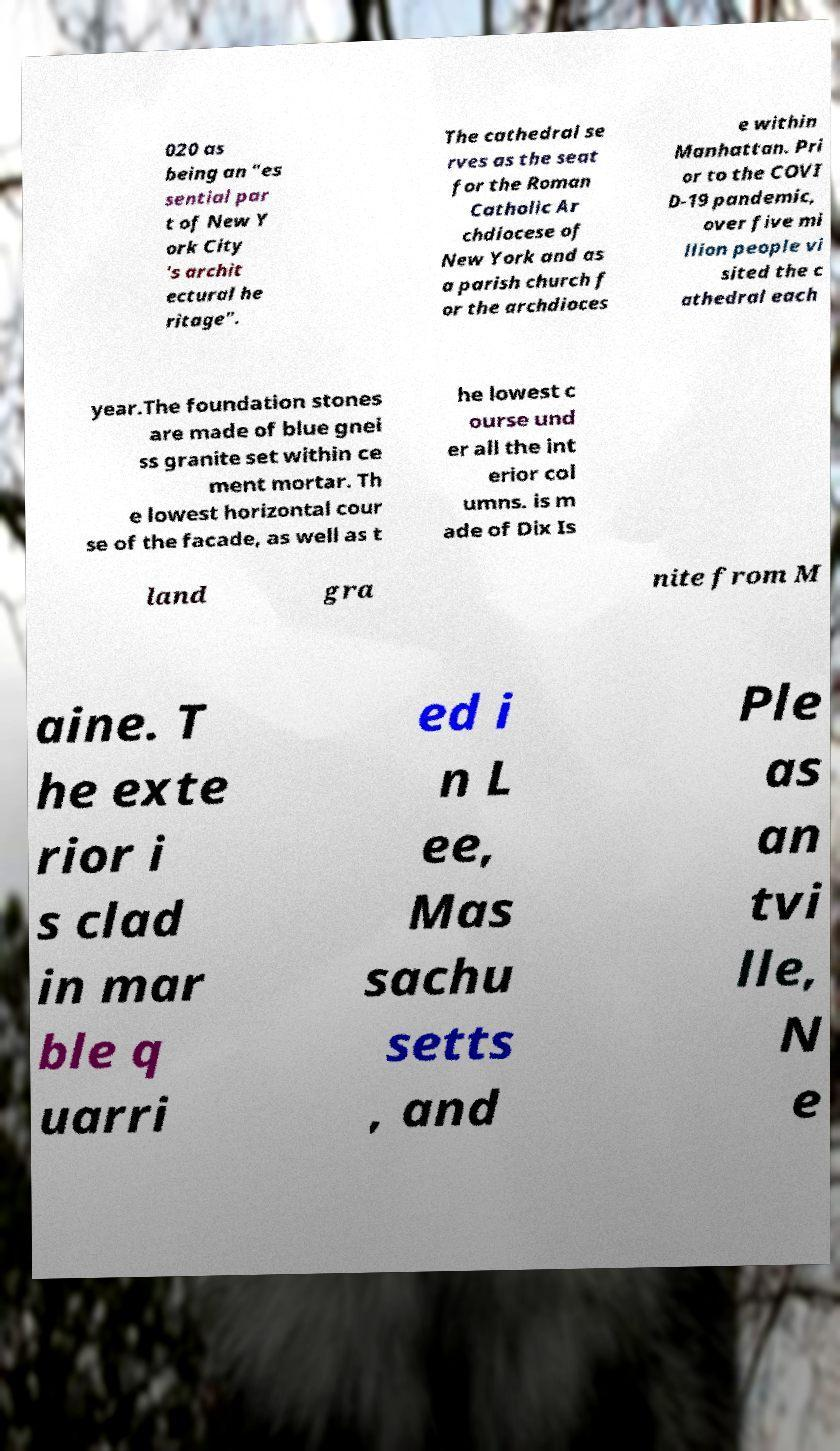Could you extract and type out the text from this image? 020 as being an "es sential par t of New Y ork City 's archit ectural he ritage". The cathedral se rves as the seat for the Roman Catholic Ar chdiocese of New York and as a parish church f or the archdioces e within Manhattan. Pri or to the COVI D-19 pandemic, over five mi llion people vi sited the c athedral each year.The foundation stones are made of blue gnei ss granite set within ce ment mortar. Th e lowest horizontal cour se of the facade, as well as t he lowest c ourse und er all the int erior col umns. is m ade of Dix Is land gra nite from M aine. T he exte rior i s clad in mar ble q uarri ed i n L ee, Mas sachu setts , and Ple as an tvi lle, N e 